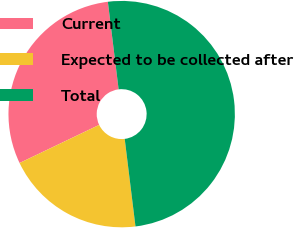Convert chart. <chart><loc_0><loc_0><loc_500><loc_500><pie_chart><fcel>Current<fcel>Expected to be collected after<fcel>Total<nl><fcel>30.16%<fcel>19.84%<fcel>50.0%<nl></chart> 